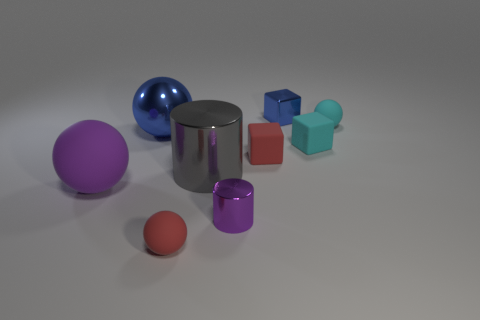Is there anything else that has the same material as the gray thing?
Your answer should be very brief. Yes. How many things are small blue metallic things or things that are left of the blue cube?
Your response must be concise. 7. There is a object right of the cyan block; is its size the same as the big blue ball?
Make the answer very short. No. How many other objects are there of the same shape as the large purple thing?
Your answer should be compact. 3. What number of purple objects are either metal cubes or matte cubes?
Offer a very short reply. 0. There is a cylinder in front of the large shiny cylinder; does it have the same color as the big matte thing?
Ensure brevity in your answer.  Yes. What is the shape of the small purple thing that is the same material as the blue cube?
Give a very brief answer. Cylinder. There is a matte object that is in front of the big blue object and on the right side of the blue cube; what color is it?
Give a very brief answer. Cyan. There is a sphere right of the small metal thing in front of the big purple matte object; what is its size?
Provide a succinct answer. Small. Is there a tiny cylinder that has the same color as the big shiny cylinder?
Provide a short and direct response. No. 